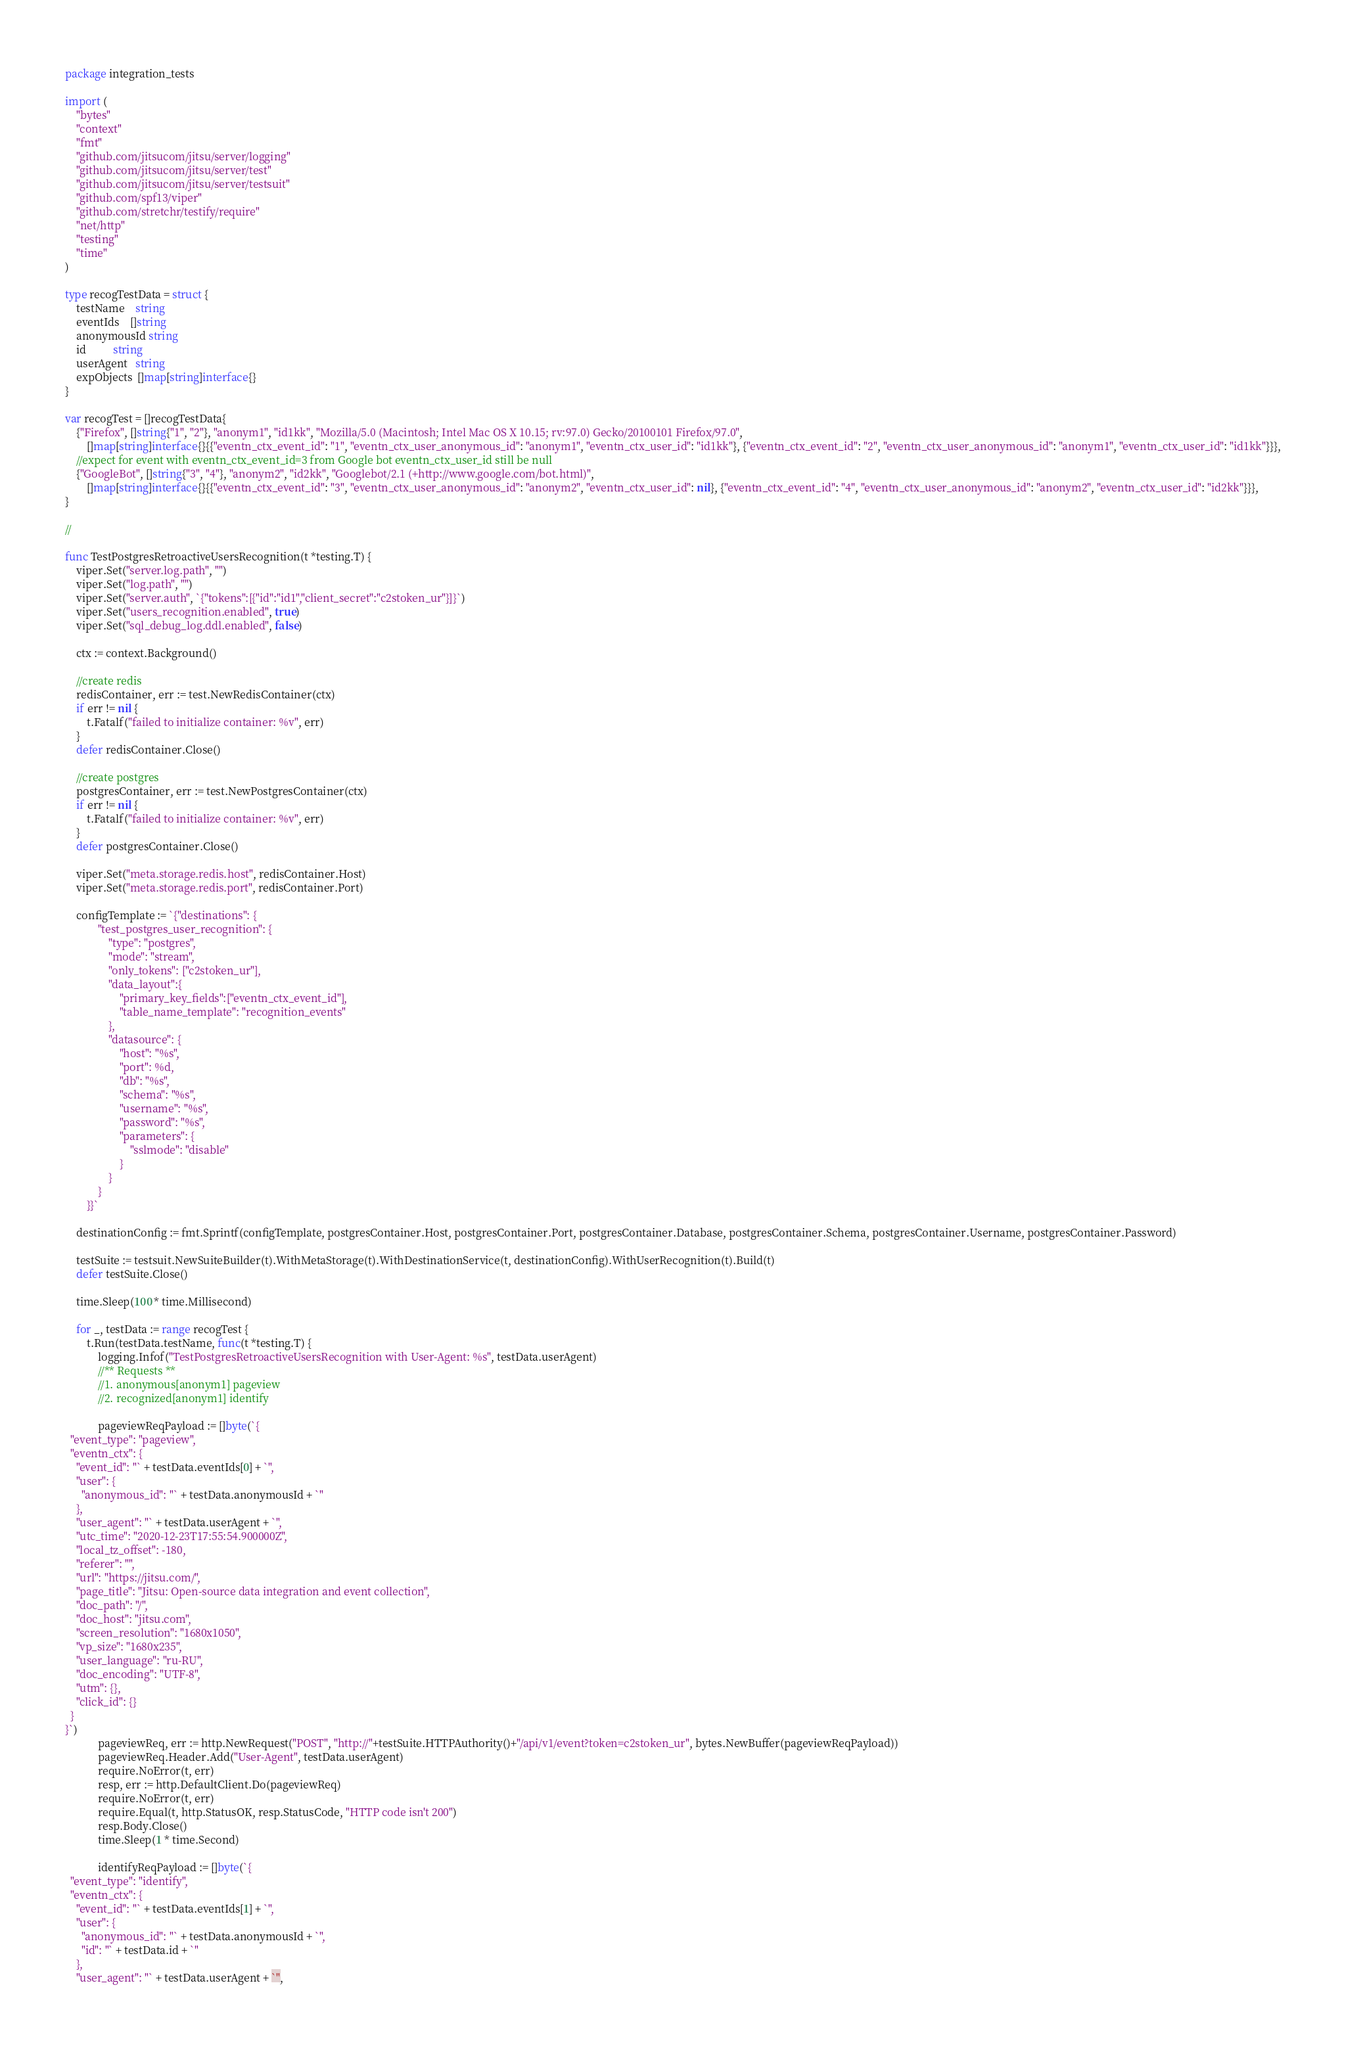<code> <loc_0><loc_0><loc_500><loc_500><_Go_>package integration_tests

import (
	"bytes"
	"context"
	"fmt"
	"github.com/jitsucom/jitsu/server/logging"
	"github.com/jitsucom/jitsu/server/test"
	"github.com/jitsucom/jitsu/server/testsuit"
	"github.com/spf13/viper"
	"github.com/stretchr/testify/require"
	"net/http"
	"testing"
	"time"
)

type recogTestData = struct {
	testName    string
	eventIds    []string
	anonymousId string
	id          string
	userAgent   string
	expObjects  []map[string]interface{}
}

var recogTest = []recogTestData{
	{"Firefox", []string{"1", "2"}, "anonym1", "id1kk", "Mozilla/5.0 (Macintosh; Intel Mac OS X 10.15; rv:97.0) Gecko/20100101 Firefox/97.0",
		[]map[string]interface{}{{"eventn_ctx_event_id": "1", "eventn_ctx_user_anonymous_id": "anonym1", "eventn_ctx_user_id": "id1kk"}, {"eventn_ctx_event_id": "2", "eventn_ctx_user_anonymous_id": "anonym1", "eventn_ctx_user_id": "id1kk"}}},
	//expect for event with eventn_ctx_event_id=3 from Google bot eventn_ctx_user_id still be null
	{"GoogleBot", []string{"3", "4"}, "anonym2", "id2kk", "Googlebot/2.1 (+http://www.google.com/bot.html)",
		[]map[string]interface{}{{"eventn_ctx_event_id": "3", "eventn_ctx_user_anonymous_id": "anonym2", "eventn_ctx_user_id": nil}, {"eventn_ctx_event_id": "4", "eventn_ctx_user_anonymous_id": "anonym2", "eventn_ctx_user_id": "id2kk"}}},
}

//

func TestPostgresRetroactiveUsersRecognition(t *testing.T) {
	viper.Set("server.log.path", "")
	viper.Set("log.path", "")
	viper.Set("server.auth", `{"tokens":[{"id":"id1","client_secret":"c2stoken_ur"}]}`)
	viper.Set("users_recognition.enabled", true)
	viper.Set("sql_debug_log.ddl.enabled", false)

	ctx := context.Background()

	//create redis
	redisContainer, err := test.NewRedisContainer(ctx)
	if err != nil {
		t.Fatalf("failed to initialize container: %v", err)
	}
	defer redisContainer.Close()

	//create postgres
	postgresContainer, err := test.NewPostgresContainer(ctx)
	if err != nil {
		t.Fatalf("failed to initialize container: %v", err)
	}
	defer postgresContainer.Close()

	viper.Set("meta.storage.redis.host", redisContainer.Host)
	viper.Set("meta.storage.redis.port", redisContainer.Port)

	configTemplate := `{"destinations": {
  			"test_postgres_user_recognition": {
        		"type": "postgres",
        		"mode": "stream",
				"only_tokens": ["c2stoken_ur"],
				"data_layout":{
                    "primary_key_fields":["eventn_ctx_event_id"],
                    "table_name_template": "recognition_events"
                },
        		"datasource": {
          			"host": "%s",
					"port": %d,
          			"db": "%s",
          			"schema": "%s",
          			"username": "%s",
          			"password": "%s",
					"parameters": {
						"sslmode": "disable"
					}
        		}
      		}
    	}}`

	destinationConfig := fmt.Sprintf(configTemplate, postgresContainer.Host, postgresContainer.Port, postgresContainer.Database, postgresContainer.Schema, postgresContainer.Username, postgresContainer.Password)

	testSuite := testsuit.NewSuiteBuilder(t).WithMetaStorage(t).WithDestinationService(t, destinationConfig).WithUserRecognition(t).Build(t)
	defer testSuite.Close()

	time.Sleep(100 * time.Millisecond)

	for _, testData := range recogTest {
		t.Run(testData.testName, func(t *testing.T) {
			logging.Infof("TestPostgresRetroactiveUsersRecognition with User-Agent: %s", testData.userAgent)
			//** Requests **
			//1. anonymous[anonym1] pageview
			//2. recognized[anonym1] identify

			pageviewReqPayload := []byte(`{
  "event_type": "pageview",
  "eventn_ctx": {
    "event_id": "` + testData.eventIds[0] + `",
    "user": {
      "anonymous_id": "` + testData.anonymousId + `"
    },
    "user_agent": "` + testData.userAgent + `",
    "utc_time": "2020-12-23T17:55:54.900000Z",
    "local_tz_offset": -180,
    "referer": "",
    "url": "https://jitsu.com/",
    "page_title": "Jitsu: Open-source data integration and event collection",
    "doc_path": "/",
    "doc_host": "jitsu.com",
    "screen_resolution": "1680x1050",
    "vp_size": "1680x235",
    "user_language": "ru-RU",
    "doc_encoding": "UTF-8",
    "utm": {},
    "click_id": {}
  }
}`)
			pageviewReq, err := http.NewRequest("POST", "http://"+testSuite.HTTPAuthority()+"/api/v1/event?token=c2stoken_ur", bytes.NewBuffer(pageviewReqPayload))
			pageviewReq.Header.Add("User-Agent", testData.userAgent)
			require.NoError(t, err)
			resp, err := http.DefaultClient.Do(pageviewReq)
			require.NoError(t, err)
			require.Equal(t, http.StatusOK, resp.StatusCode, "HTTP code isn't 200")
			resp.Body.Close()
			time.Sleep(1 * time.Second)

			identifyReqPayload := []byte(`{
  "event_type": "identify",
  "eventn_ctx": {
    "event_id": "` + testData.eventIds[1] + `",
    "user": {
      "anonymous_id": "` + testData.anonymousId + `",
      "id": "` + testData.id + `"
    },
    "user_agent": "` + testData.userAgent + `",</code> 